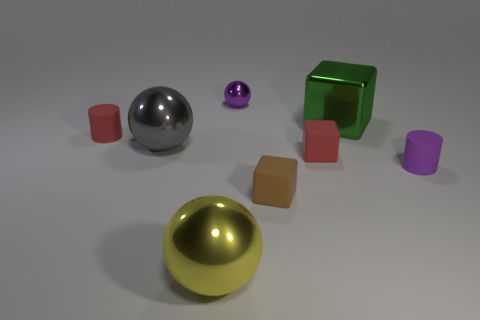Add 1 red cylinders. How many objects exist? 9 Subtract all blocks. How many objects are left? 5 Add 5 big gray balls. How many big gray balls exist? 6 Subtract 0 yellow blocks. How many objects are left? 8 Subtract all shiny balls. Subtract all small red cubes. How many objects are left? 4 Add 5 purple cylinders. How many purple cylinders are left? 6 